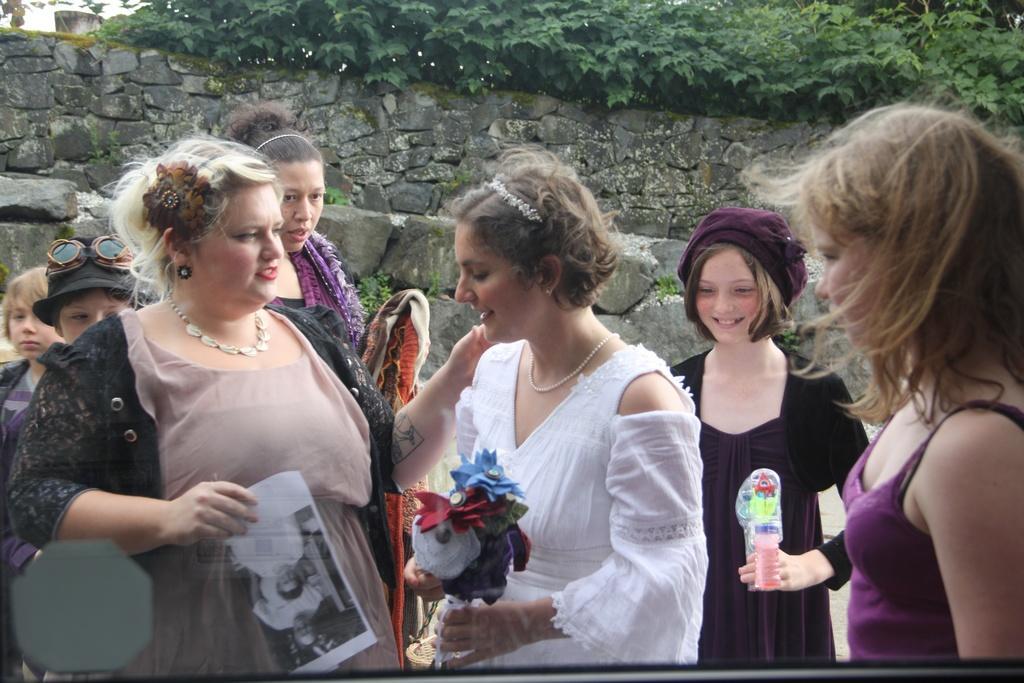Could you give a brief overview of what you see in this image? In this image a woman wearing a white dress is holding artificial flowers in her hand. Behind there is a woman wearing a black dress is holding a toy in her hand. She is wearing a cap. Left side there is a woman holding a paper. Behind there are few persons. Behind them there is a wall. Top of image there are few trees and a building. 